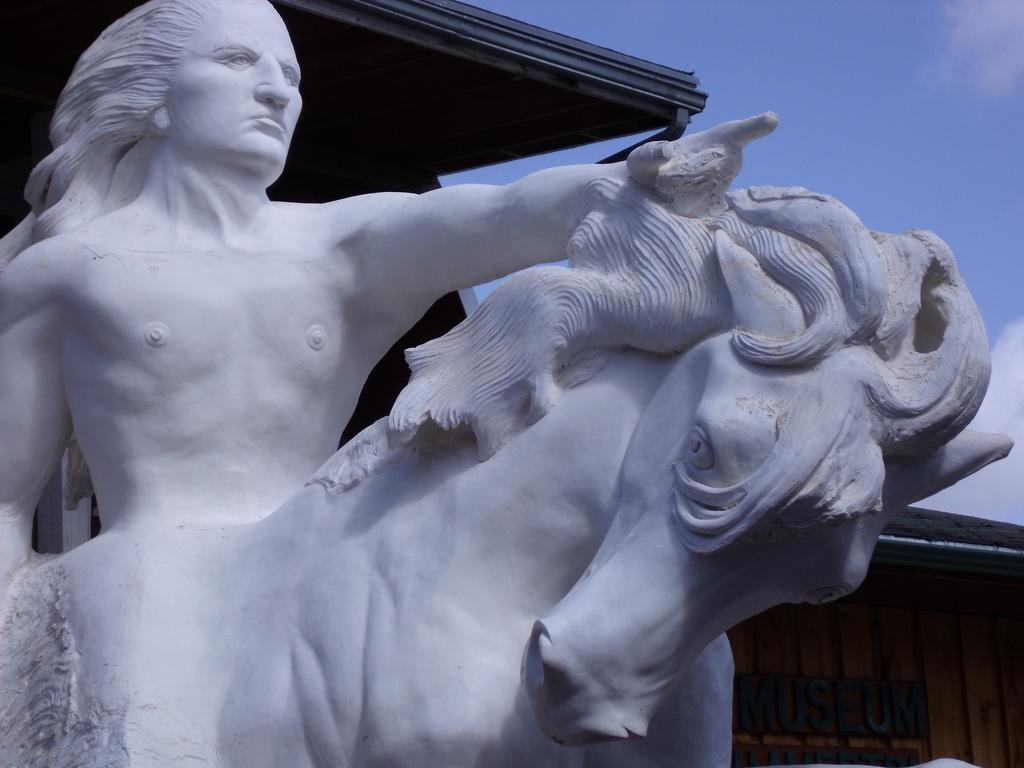What is the main subject in the image? There is a statue in the image. Is there any text or label associated with the statue? Yes, there is a name board in the image. What can be seen in the background of the image? The sky is visible in the image, and clouds are present in the sky. How many jellyfish are swimming around the statue in the image? There are no jellyfish present in the image; it features a statue and a name board. What type of muscle is being exercised by the statue in the image? The statue is not a living being and does not have muscles; it is a non-living object. 